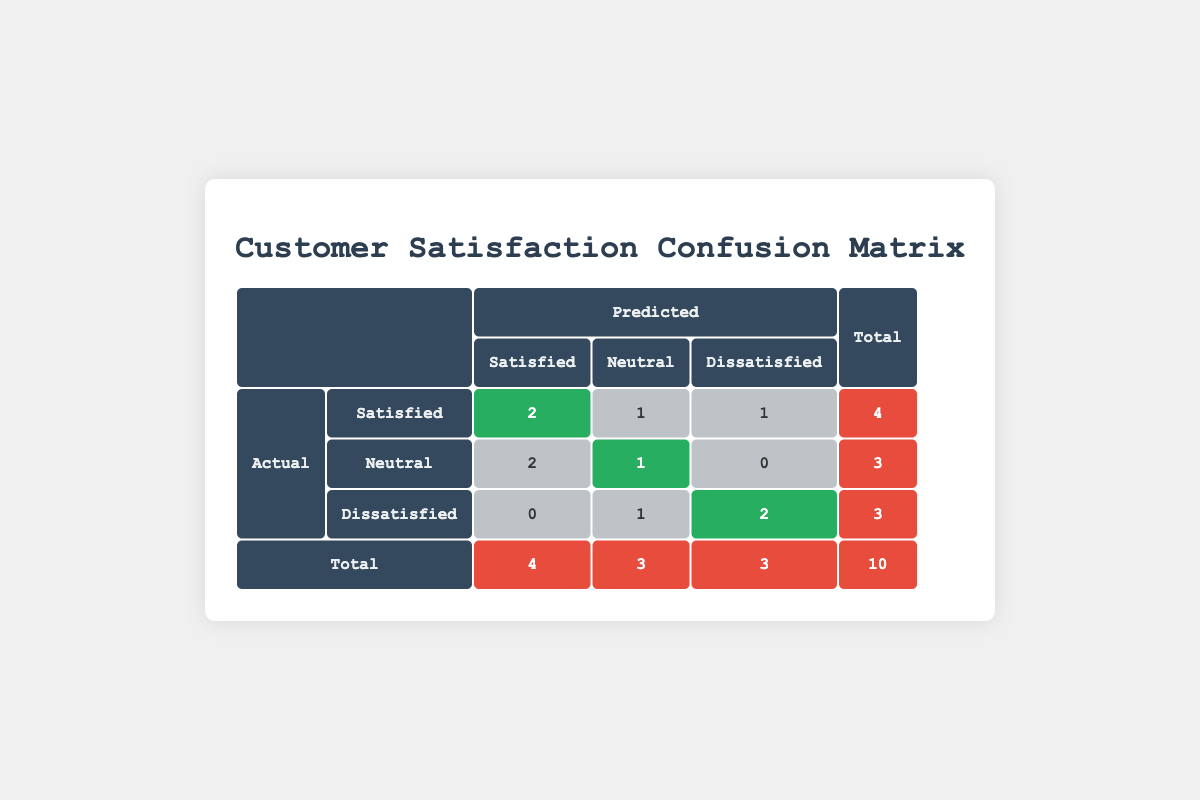What is the total number of customers classified as 'Satisfied'? To find the total number of 'Satisfied' customers, we need to look at the total in the 'Satisfied' row. From the table, we see there are a total of 4 customers who are classified as 'Satisfied'.
Answer: 4 How many customers predicted to be 'Dissatisfied' were actually 'Satisfied'? In the 'Dissatisfied' row, we check how many customers were predicted as 'Dissatisfied.' In the table, the cell under 'Dissatisfied' where 'Satisfied' is the actual satisfaction shows 0 customers, indicating none were predicted to be 'Dissatisfied' among those who were actually 'Satisfied.'
Answer: 0 What is the total number of customers who are 'Neutral'? To find the total number of 'Neutral' customers, we sum the customers in the 'Neutral' row. The total for 'Neutral' customers is 3 according to the table.
Answer: 3 Is it true that all customers predicted to be 'Neutral' were actually 'Neutral'? Looking at the 'Neutral' predicted column, we see there is one instance where a customer predicted as 'Neutral' was 'Dissatisfied.' Therefore, it's not true that all predicted as 'Neutral' were actually 'Neutral.'
Answer: No How many customers were classified as 'Dissatisfied' but were predicted as 'Satisfied'? In the 'Dissatisfied' row, we look where the predicted satisfaction is 'Satisfied.' The cell shows 0 customers classified as 'Dissatisfied' yet predicted as 'Satisfied.'
Answer: 0 What is the total count of misclassifications for 'Satisfied' predictions? Misclassifications occur when the actual satisfaction does not match the predicted satisfaction. For 'Satisfied' predictions, we have 1 customer who was actually 'Neutral' and 1 who was actually 'Dissatisfied.' Thus, misclassifications total 2.
Answer: 2 What percentage of customers who were actually 'Dissatisfied' were correctly predicted as 'Dissatisfied'? We first note the total 'Dissatisfied' customers (which is 3) and recognize that 2 were correctly predicted as 'Dissatisfied.' So, (2/3) * 100% = 66.67%, rounded 67%.
Answer: 67% In total, how many customers were correctly predicted? To find this, we sum the 'Satisfied' and 'Neutral' correct predictions, which are 2 + 1 + 2 = 5 correct predictions out of 10 total customers.
Answer: 5 